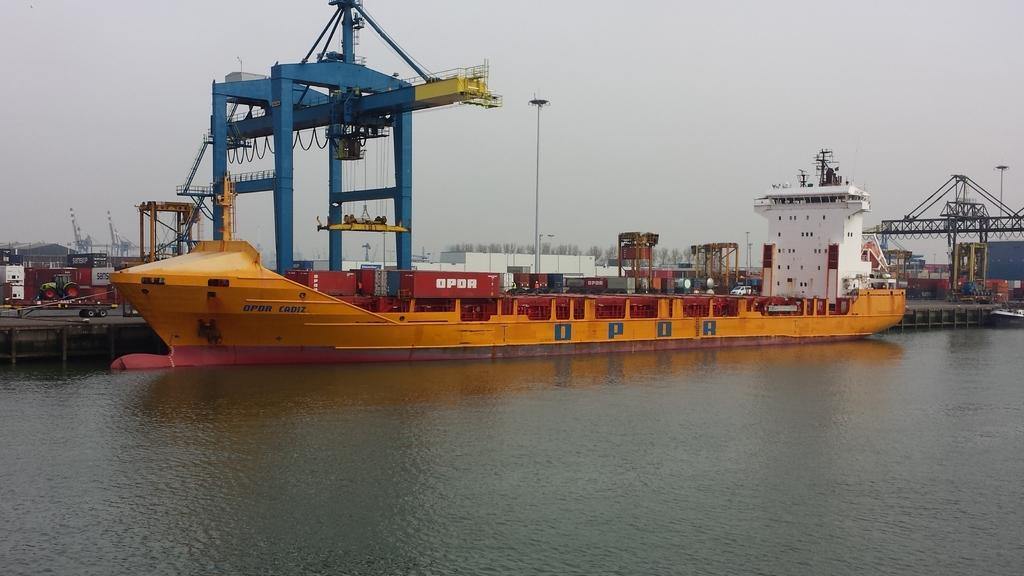Please provide a concise description of this image. This picture is clicked outside the city. In the foreground we can see an orange color object seems to be the boat in the water body and we can see the metal rods and some metal objects. In the background we can see the sky, trees, buildings, metal rods, vehicles and many other objects. 